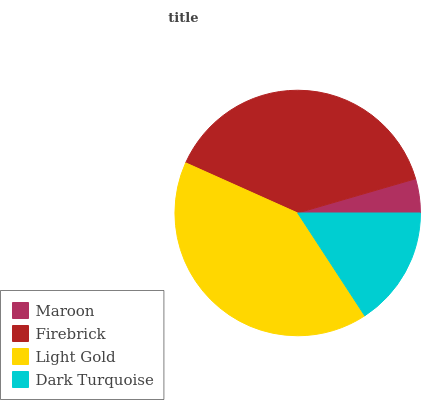Is Maroon the minimum?
Answer yes or no. Yes. Is Light Gold the maximum?
Answer yes or no. Yes. Is Firebrick the minimum?
Answer yes or no. No. Is Firebrick the maximum?
Answer yes or no. No. Is Firebrick greater than Maroon?
Answer yes or no. Yes. Is Maroon less than Firebrick?
Answer yes or no. Yes. Is Maroon greater than Firebrick?
Answer yes or no. No. Is Firebrick less than Maroon?
Answer yes or no. No. Is Firebrick the high median?
Answer yes or no. Yes. Is Dark Turquoise the low median?
Answer yes or no. Yes. Is Light Gold the high median?
Answer yes or no. No. Is Firebrick the low median?
Answer yes or no. No. 